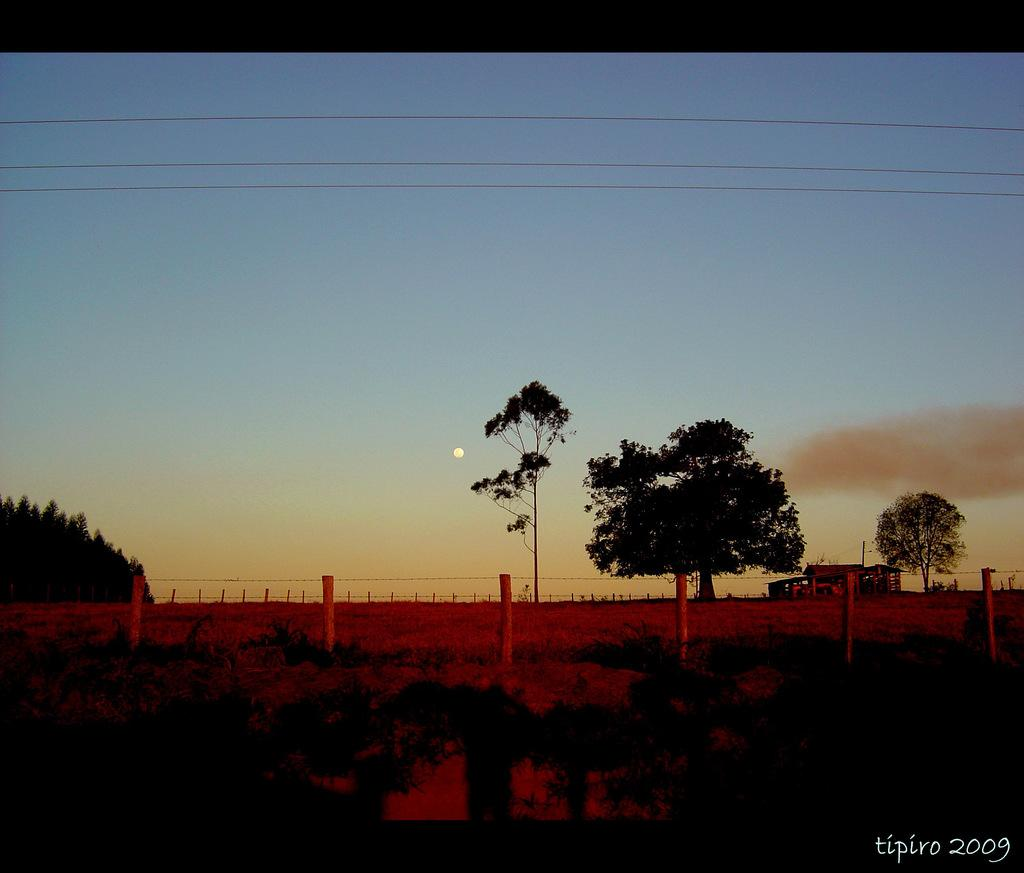What type of vegetation is present in the image? There are bamboos and trees in the image. Can you describe the boundary in the image? The boundary is in the center of the image. What is visible in the sky in the background of the image? There is a moon in the sky in the background. Is there any indication of a man-made structure in the background? There may be a house in the background area. What type of furniture can be seen in the image? There is no furniture present in the image. How many crows are perched on the bamboos in the image? There are no crows visible in the image. 